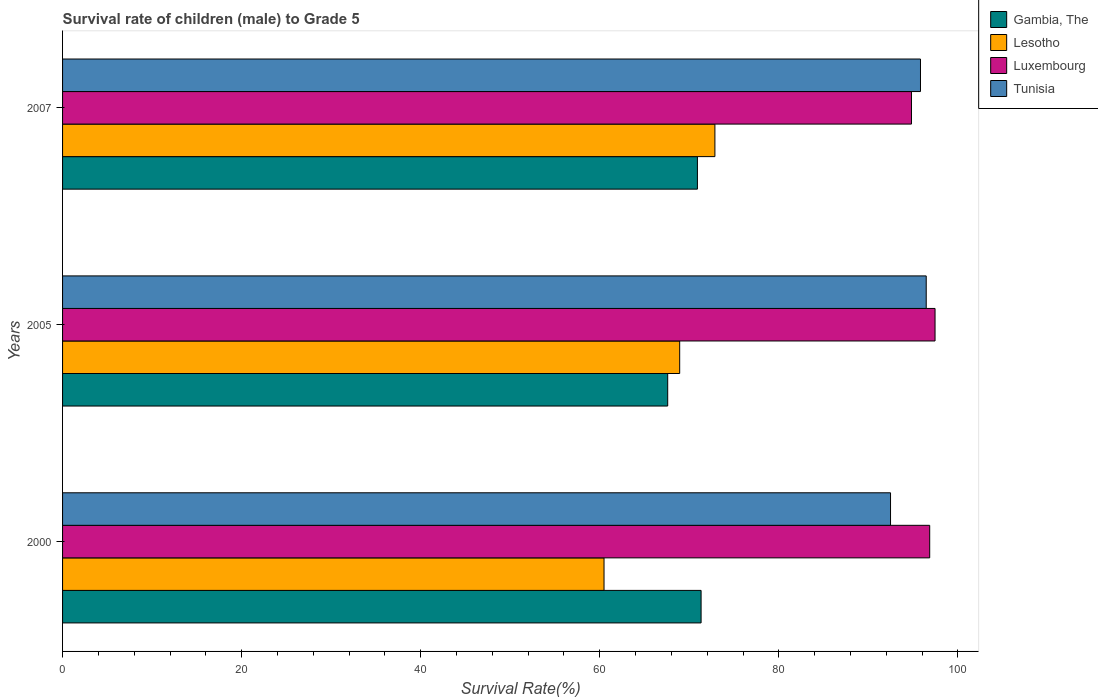How many groups of bars are there?
Your response must be concise. 3. Are the number of bars per tick equal to the number of legend labels?
Your response must be concise. Yes. How many bars are there on the 3rd tick from the bottom?
Ensure brevity in your answer.  4. What is the survival rate of male children to grade 5 in Tunisia in 2007?
Provide a short and direct response. 95.82. Across all years, what is the maximum survival rate of male children to grade 5 in Gambia, The?
Provide a succinct answer. 71.32. Across all years, what is the minimum survival rate of male children to grade 5 in Tunisia?
Ensure brevity in your answer.  92.48. In which year was the survival rate of male children to grade 5 in Gambia, The maximum?
Your response must be concise. 2000. What is the total survival rate of male children to grade 5 in Tunisia in the graph?
Keep it short and to the point. 284.76. What is the difference between the survival rate of male children to grade 5 in Tunisia in 2005 and that in 2007?
Provide a short and direct response. 0.64. What is the difference between the survival rate of male children to grade 5 in Lesotho in 2005 and the survival rate of male children to grade 5 in Tunisia in 2007?
Give a very brief answer. -26.9. What is the average survival rate of male children to grade 5 in Luxembourg per year?
Provide a succinct answer. 96.37. In the year 2000, what is the difference between the survival rate of male children to grade 5 in Gambia, The and survival rate of male children to grade 5 in Lesotho?
Make the answer very short. 10.84. In how many years, is the survival rate of male children to grade 5 in Lesotho greater than 64 %?
Your answer should be compact. 2. What is the ratio of the survival rate of male children to grade 5 in Lesotho in 2000 to that in 2007?
Your answer should be very brief. 0.83. Is the difference between the survival rate of male children to grade 5 in Gambia, The in 2000 and 2007 greater than the difference between the survival rate of male children to grade 5 in Lesotho in 2000 and 2007?
Your answer should be very brief. Yes. What is the difference between the highest and the second highest survival rate of male children to grade 5 in Lesotho?
Provide a succinct answer. 3.93. What is the difference between the highest and the lowest survival rate of male children to grade 5 in Gambia, The?
Keep it short and to the point. 3.73. In how many years, is the survival rate of male children to grade 5 in Luxembourg greater than the average survival rate of male children to grade 5 in Luxembourg taken over all years?
Your response must be concise. 2. Is the sum of the survival rate of male children to grade 5 in Lesotho in 2005 and 2007 greater than the maximum survival rate of male children to grade 5 in Tunisia across all years?
Your answer should be very brief. Yes. What does the 1st bar from the top in 2000 represents?
Provide a short and direct response. Tunisia. What does the 2nd bar from the bottom in 2005 represents?
Provide a succinct answer. Lesotho. How many bars are there?
Offer a very short reply. 12. Are all the bars in the graph horizontal?
Your answer should be compact. Yes. Does the graph contain any zero values?
Give a very brief answer. No. Does the graph contain grids?
Your response must be concise. No. Where does the legend appear in the graph?
Provide a succinct answer. Top right. How many legend labels are there?
Offer a terse response. 4. How are the legend labels stacked?
Ensure brevity in your answer.  Vertical. What is the title of the graph?
Your answer should be very brief. Survival rate of children (male) to Grade 5. Does "Sierra Leone" appear as one of the legend labels in the graph?
Offer a very short reply. No. What is the label or title of the X-axis?
Offer a terse response. Survival Rate(%). What is the label or title of the Y-axis?
Your response must be concise. Years. What is the Survival Rate(%) in Gambia, The in 2000?
Keep it short and to the point. 71.32. What is the Survival Rate(%) of Lesotho in 2000?
Your response must be concise. 60.48. What is the Survival Rate(%) of Luxembourg in 2000?
Provide a short and direct response. 96.85. What is the Survival Rate(%) in Tunisia in 2000?
Give a very brief answer. 92.48. What is the Survival Rate(%) of Gambia, The in 2005?
Keep it short and to the point. 67.59. What is the Survival Rate(%) of Lesotho in 2005?
Your response must be concise. 68.93. What is the Survival Rate(%) of Luxembourg in 2005?
Make the answer very short. 97.45. What is the Survival Rate(%) in Tunisia in 2005?
Provide a succinct answer. 96.46. What is the Survival Rate(%) in Gambia, The in 2007?
Your response must be concise. 70.91. What is the Survival Rate(%) of Lesotho in 2007?
Offer a very short reply. 72.86. What is the Survival Rate(%) in Luxembourg in 2007?
Keep it short and to the point. 94.81. What is the Survival Rate(%) in Tunisia in 2007?
Your answer should be very brief. 95.82. Across all years, what is the maximum Survival Rate(%) of Gambia, The?
Give a very brief answer. 71.32. Across all years, what is the maximum Survival Rate(%) in Lesotho?
Your response must be concise. 72.86. Across all years, what is the maximum Survival Rate(%) of Luxembourg?
Provide a short and direct response. 97.45. Across all years, what is the maximum Survival Rate(%) in Tunisia?
Offer a terse response. 96.46. Across all years, what is the minimum Survival Rate(%) of Gambia, The?
Your response must be concise. 67.59. Across all years, what is the minimum Survival Rate(%) of Lesotho?
Provide a short and direct response. 60.48. Across all years, what is the minimum Survival Rate(%) of Luxembourg?
Your answer should be very brief. 94.81. Across all years, what is the minimum Survival Rate(%) of Tunisia?
Offer a very short reply. 92.48. What is the total Survival Rate(%) in Gambia, The in the graph?
Give a very brief answer. 209.81. What is the total Survival Rate(%) of Lesotho in the graph?
Offer a very short reply. 202.26. What is the total Survival Rate(%) of Luxembourg in the graph?
Your response must be concise. 289.11. What is the total Survival Rate(%) in Tunisia in the graph?
Provide a short and direct response. 284.76. What is the difference between the Survival Rate(%) of Gambia, The in 2000 and that in 2005?
Ensure brevity in your answer.  3.73. What is the difference between the Survival Rate(%) in Lesotho in 2000 and that in 2005?
Your response must be concise. -8.45. What is the difference between the Survival Rate(%) of Luxembourg in 2000 and that in 2005?
Your answer should be compact. -0.6. What is the difference between the Survival Rate(%) of Tunisia in 2000 and that in 2005?
Ensure brevity in your answer.  -3.99. What is the difference between the Survival Rate(%) in Gambia, The in 2000 and that in 2007?
Provide a short and direct response. 0.41. What is the difference between the Survival Rate(%) in Lesotho in 2000 and that in 2007?
Offer a very short reply. -12.38. What is the difference between the Survival Rate(%) in Luxembourg in 2000 and that in 2007?
Ensure brevity in your answer.  2.04. What is the difference between the Survival Rate(%) of Tunisia in 2000 and that in 2007?
Your answer should be very brief. -3.35. What is the difference between the Survival Rate(%) of Gambia, The in 2005 and that in 2007?
Keep it short and to the point. -3.32. What is the difference between the Survival Rate(%) in Lesotho in 2005 and that in 2007?
Ensure brevity in your answer.  -3.93. What is the difference between the Survival Rate(%) in Luxembourg in 2005 and that in 2007?
Provide a succinct answer. 2.63. What is the difference between the Survival Rate(%) in Tunisia in 2005 and that in 2007?
Provide a succinct answer. 0.64. What is the difference between the Survival Rate(%) of Gambia, The in 2000 and the Survival Rate(%) of Lesotho in 2005?
Provide a succinct answer. 2.39. What is the difference between the Survival Rate(%) in Gambia, The in 2000 and the Survival Rate(%) in Luxembourg in 2005?
Provide a succinct answer. -26.13. What is the difference between the Survival Rate(%) in Gambia, The in 2000 and the Survival Rate(%) in Tunisia in 2005?
Ensure brevity in your answer.  -25.14. What is the difference between the Survival Rate(%) in Lesotho in 2000 and the Survival Rate(%) in Luxembourg in 2005?
Make the answer very short. -36.97. What is the difference between the Survival Rate(%) of Lesotho in 2000 and the Survival Rate(%) of Tunisia in 2005?
Provide a short and direct response. -35.99. What is the difference between the Survival Rate(%) of Luxembourg in 2000 and the Survival Rate(%) of Tunisia in 2005?
Provide a short and direct response. 0.39. What is the difference between the Survival Rate(%) in Gambia, The in 2000 and the Survival Rate(%) in Lesotho in 2007?
Your answer should be very brief. -1.54. What is the difference between the Survival Rate(%) of Gambia, The in 2000 and the Survival Rate(%) of Luxembourg in 2007?
Give a very brief answer. -23.5. What is the difference between the Survival Rate(%) in Gambia, The in 2000 and the Survival Rate(%) in Tunisia in 2007?
Provide a short and direct response. -24.5. What is the difference between the Survival Rate(%) of Lesotho in 2000 and the Survival Rate(%) of Luxembourg in 2007?
Provide a short and direct response. -34.34. What is the difference between the Survival Rate(%) in Lesotho in 2000 and the Survival Rate(%) in Tunisia in 2007?
Offer a terse response. -35.35. What is the difference between the Survival Rate(%) of Luxembourg in 2000 and the Survival Rate(%) of Tunisia in 2007?
Ensure brevity in your answer.  1.03. What is the difference between the Survival Rate(%) of Gambia, The in 2005 and the Survival Rate(%) of Lesotho in 2007?
Offer a terse response. -5.27. What is the difference between the Survival Rate(%) of Gambia, The in 2005 and the Survival Rate(%) of Luxembourg in 2007?
Provide a short and direct response. -27.23. What is the difference between the Survival Rate(%) of Gambia, The in 2005 and the Survival Rate(%) of Tunisia in 2007?
Provide a succinct answer. -28.23. What is the difference between the Survival Rate(%) of Lesotho in 2005 and the Survival Rate(%) of Luxembourg in 2007?
Offer a terse response. -25.89. What is the difference between the Survival Rate(%) of Lesotho in 2005 and the Survival Rate(%) of Tunisia in 2007?
Give a very brief answer. -26.9. What is the difference between the Survival Rate(%) of Luxembourg in 2005 and the Survival Rate(%) of Tunisia in 2007?
Offer a very short reply. 1.63. What is the average Survival Rate(%) of Gambia, The per year?
Your response must be concise. 69.94. What is the average Survival Rate(%) in Lesotho per year?
Ensure brevity in your answer.  67.42. What is the average Survival Rate(%) of Luxembourg per year?
Keep it short and to the point. 96.37. What is the average Survival Rate(%) of Tunisia per year?
Your response must be concise. 94.92. In the year 2000, what is the difference between the Survival Rate(%) in Gambia, The and Survival Rate(%) in Lesotho?
Offer a terse response. 10.84. In the year 2000, what is the difference between the Survival Rate(%) of Gambia, The and Survival Rate(%) of Luxembourg?
Make the answer very short. -25.53. In the year 2000, what is the difference between the Survival Rate(%) of Gambia, The and Survival Rate(%) of Tunisia?
Offer a very short reply. -21.16. In the year 2000, what is the difference between the Survival Rate(%) in Lesotho and Survival Rate(%) in Luxembourg?
Offer a terse response. -36.38. In the year 2000, what is the difference between the Survival Rate(%) in Lesotho and Survival Rate(%) in Tunisia?
Your answer should be compact. -32. In the year 2000, what is the difference between the Survival Rate(%) of Luxembourg and Survival Rate(%) of Tunisia?
Give a very brief answer. 4.38. In the year 2005, what is the difference between the Survival Rate(%) of Gambia, The and Survival Rate(%) of Lesotho?
Provide a succinct answer. -1.34. In the year 2005, what is the difference between the Survival Rate(%) of Gambia, The and Survival Rate(%) of Luxembourg?
Provide a succinct answer. -29.86. In the year 2005, what is the difference between the Survival Rate(%) in Gambia, The and Survival Rate(%) in Tunisia?
Ensure brevity in your answer.  -28.87. In the year 2005, what is the difference between the Survival Rate(%) in Lesotho and Survival Rate(%) in Luxembourg?
Ensure brevity in your answer.  -28.52. In the year 2005, what is the difference between the Survival Rate(%) in Lesotho and Survival Rate(%) in Tunisia?
Make the answer very short. -27.54. In the year 2007, what is the difference between the Survival Rate(%) in Gambia, The and Survival Rate(%) in Lesotho?
Offer a terse response. -1.95. In the year 2007, what is the difference between the Survival Rate(%) of Gambia, The and Survival Rate(%) of Luxembourg?
Make the answer very short. -23.91. In the year 2007, what is the difference between the Survival Rate(%) of Gambia, The and Survival Rate(%) of Tunisia?
Your answer should be compact. -24.91. In the year 2007, what is the difference between the Survival Rate(%) in Lesotho and Survival Rate(%) in Luxembourg?
Offer a very short reply. -21.95. In the year 2007, what is the difference between the Survival Rate(%) of Lesotho and Survival Rate(%) of Tunisia?
Your answer should be very brief. -22.96. In the year 2007, what is the difference between the Survival Rate(%) in Luxembourg and Survival Rate(%) in Tunisia?
Offer a very short reply. -1.01. What is the ratio of the Survival Rate(%) in Gambia, The in 2000 to that in 2005?
Your answer should be very brief. 1.06. What is the ratio of the Survival Rate(%) of Lesotho in 2000 to that in 2005?
Keep it short and to the point. 0.88. What is the ratio of the Survival Rate(%) of Tunisia in 2000 to that in 2005?
Your answer should be compact. 0.96. What is the ratio of the Survival Rate(%) in Gambia, The in 2000 to that in 2007?
Make the answer very short. 1.01. What is the ratio of the Survival Rate(%) in Lesotho in 2000 to that in 2007?
Give a very brief answer. 0.83. What is the ratio of the Survival Rate(%) in Luxembourg in 2000 to that in 2007?
Your response must be concise. 1.02. What is the ratio of the Survival Rate(%) in Tunisia in 2000 to that in 2007?
Your response must be concise. 0.97. What is the ratio of the Survival Rate(%) of Gambia, The in 2005 to that in 2007?
Your answer should be very brief. 0.95. What is the ratio of the Survival Rate(%) in Lesotho in 2005 to that in 2007?
Provide a short and direct response. 0.95. What is the ratio of the Survival Rate(%) in Luxembourg in 2005 to that in 2007?
Provide a succinct answer. 1.03. What is the difference between the highest and the second highest Survival Rate(%) in Gambia, The?
Give a very brief answer. 0.41. What is the difference between the highest and the second highest Survival Rate(%) in Lesotho?
Provide a succinct answer. 3.93. What is the difference between the highest and the second highest Survival Rate(%) of Luxembourg?
Give a very brief answer. 0.6. What is the difference between the highest and the second highest Survival Rate(%) in Tunisia?
Provide a succinct answer. 0.64. What is the difference between the highest and the lowest Survival Rate(%) in Gambia, The?
Provide a short and direct response. 3.73. What is the difference between the highest and the lowest Survival Rate(%) of Lesotho?
Your answer should be compact. 12.38. What is the difference between the highest and the lowest Survival Rate(%) in Luxembourg?
Your answer should be compact. 2.63. What is the difference between the highest and the lowest Survival Rate(%) in Tunisia?
Keep it short and to the point. 3.99. 